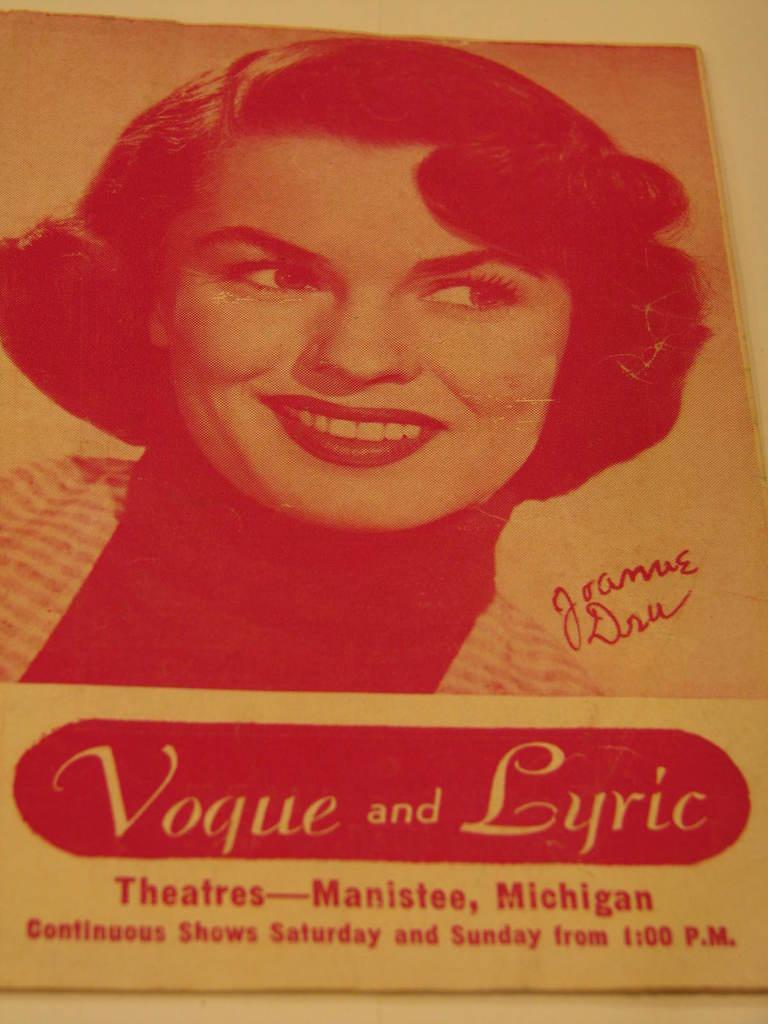What is present in the image that features a design or message? There is a poster in the image. Where is the poster located? The poster is on a surface. What can be seen on the poster? There is a person depicted on the poster, and there is also text on the poster. How many legs does the person depicted on the poster have? The person depicted on the poster does not have any legs, as it is a two-dimensional image. 